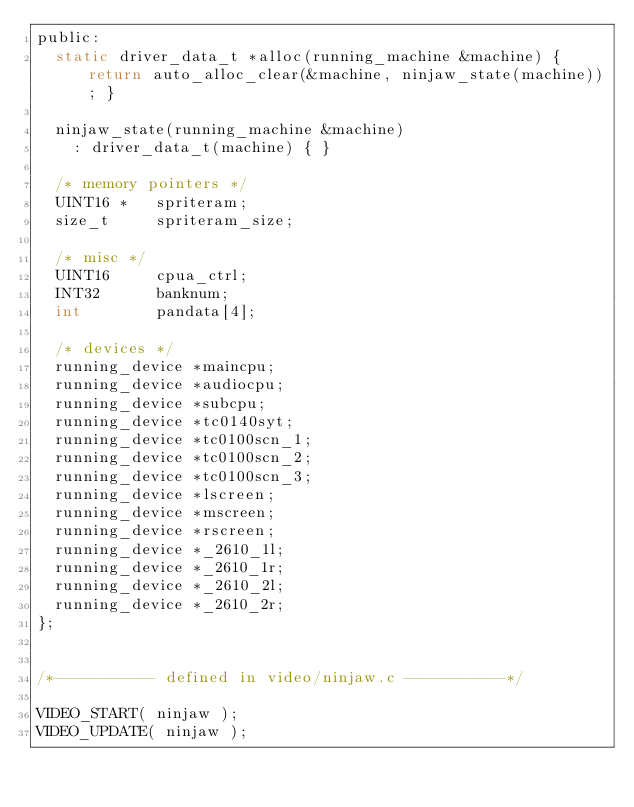<code> <loc_0><loc_0><loc_500><loc_500><_C_>public:
	static driver_data_t *alloc(running_machine &machine) { return auto_alloc_clear(&machine, ninjaw_state(machine)); }

	ninjaw_state(running_machine &machine)
		: driver_data_t(machine) { }

	/* memory pointers */
	UINT16 *   spriteram;
	size_t     spriteram_size;

	/* misc */
	UINT16     cpua_ctrl;
	INT32      banknum;
	int        pandata[4];

	/* devices */
	running_device *maincpu;
	running_device *audiocpu;
	running_device *subcpu;
	running_device *tc0140syt;
	running_device *tc0100scn_1;
	running_device *tc0100scn_2;
	running_device *tc0100scn_3;
	running_device *lscreen;
	running_device *mscreen;
	running_device *rscreen;
	running_device *_2610_1l;
	running_device *_2610_1r;
	running_device *_2610_2l;
	running_device *_2610_2r;
};


/*----------- defined in video/ninjaw.c -----------*/

VIDEO_START( ninjaw );
VIDEO_UPDATE( ninjaw );
</code> 